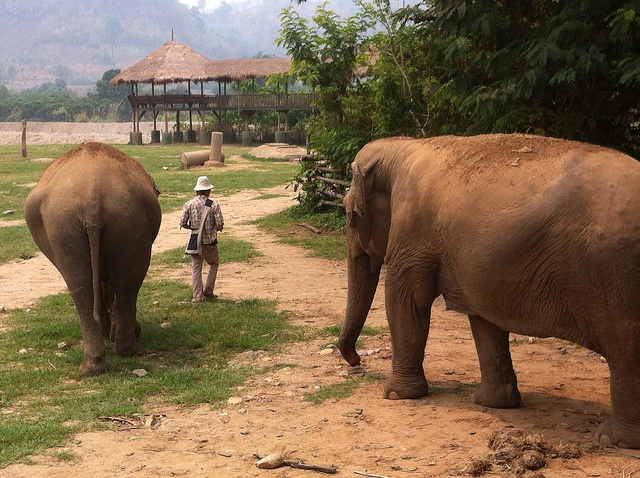Describe the objects in this image and their specific colors. I can see elephant in lavender, black, maroon, and gray tones, elephant in lavender, black, gray, and maroon tones, people in lavender, maroon, gray, and black tones, and handbag in lavender, black, gray, darkgray, and tan tones in this image. 